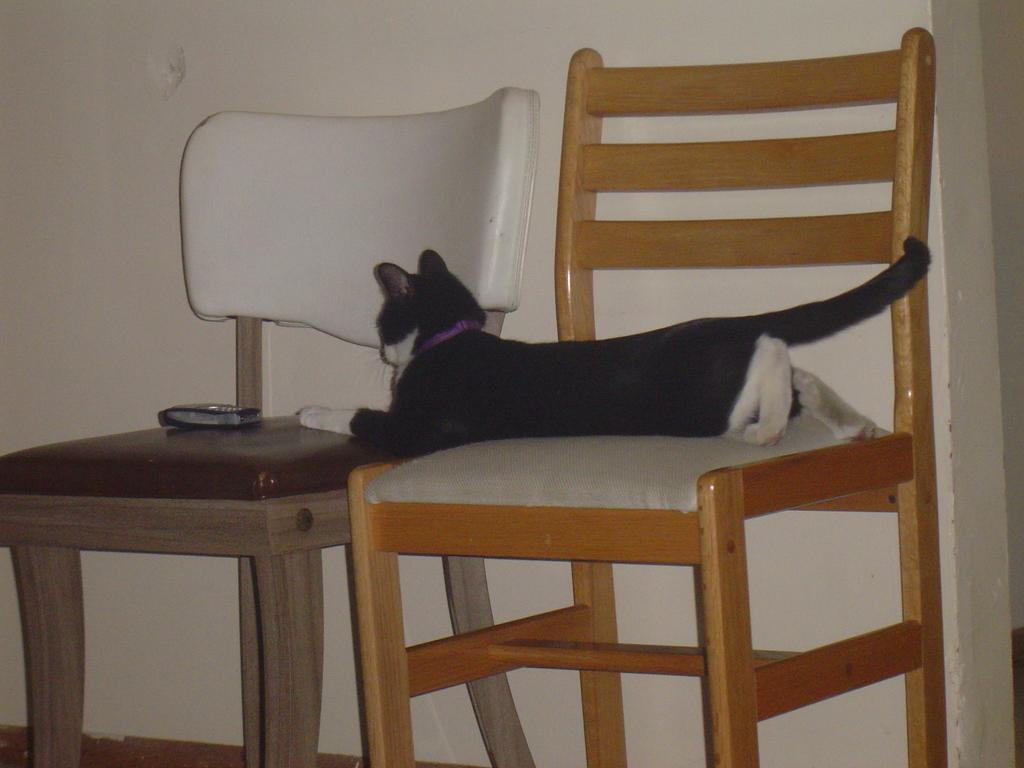How many chairs are visible in the image? There are two chairs in the image. What is sitting on one of the chairs? A cat is sitting on one of the chairs. What is on the other chair? There is a mobile on the other chair. What color is the wall in the background of the image? The wall in the background of the image is white. What grade did the cat receive on its test in the image? There is no test or grade mentioned in the image, as it features a cat sitting on a chair and a mobile on another chair. 